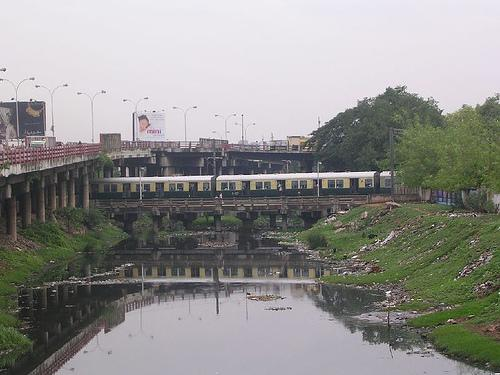What is the problem in this area? litter 